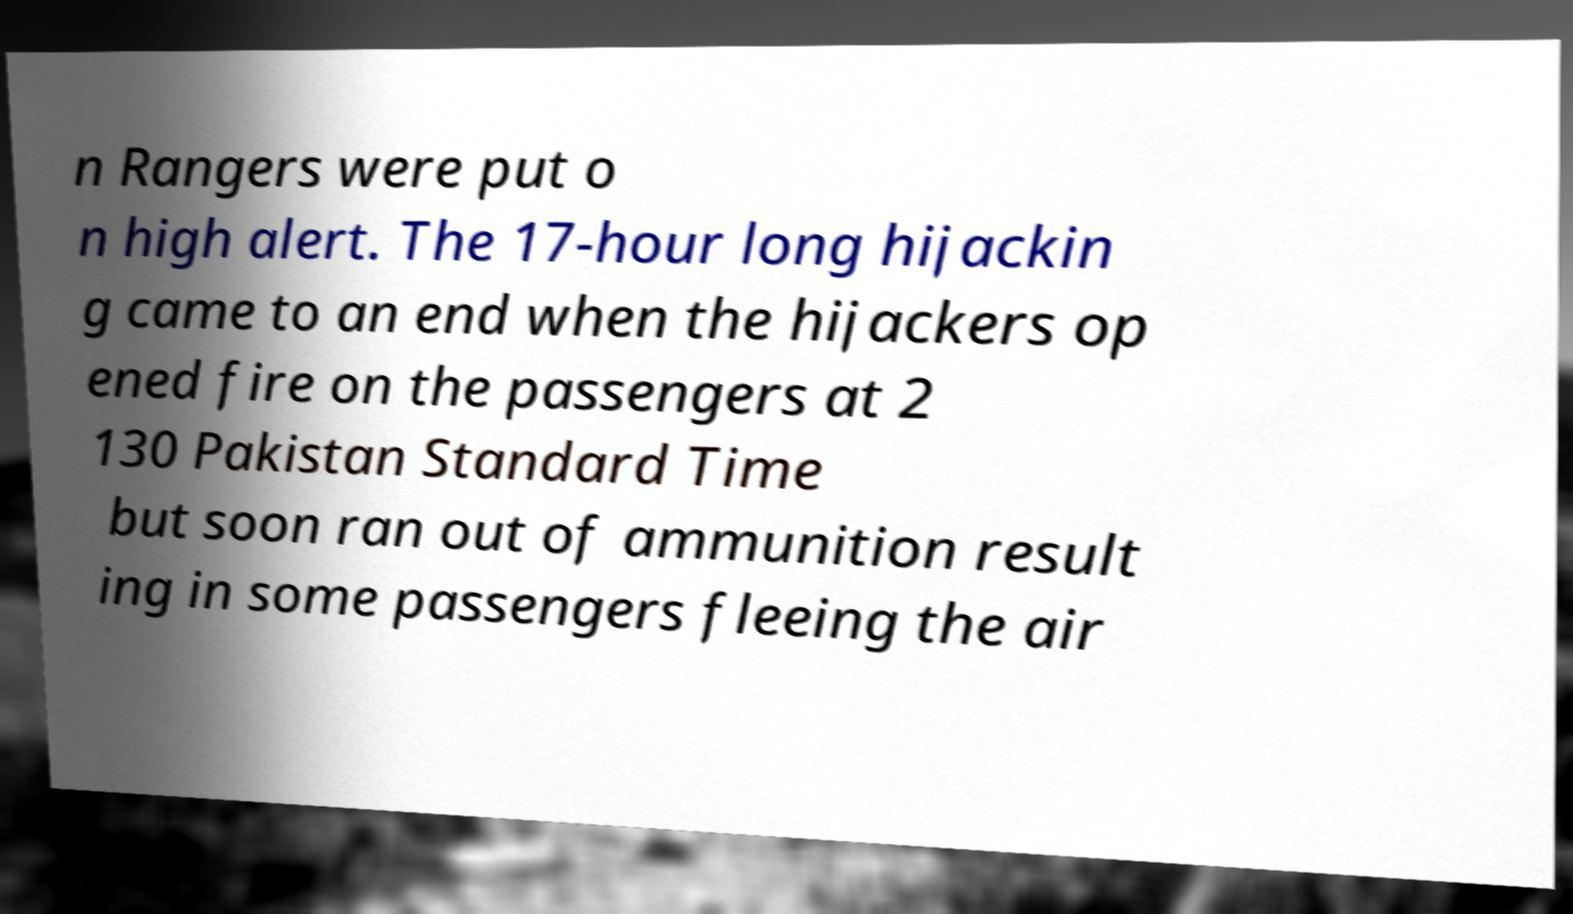Please identify and transcribe the text found in this image. n Rangers were put o n high alert. The 17-hour long hijackin g came to an end when the hijackers op ened fire on the passengers at 2 130 Pakistan Standard Time but soon ran out of ammunition result ing in some passengers fleeing the air 